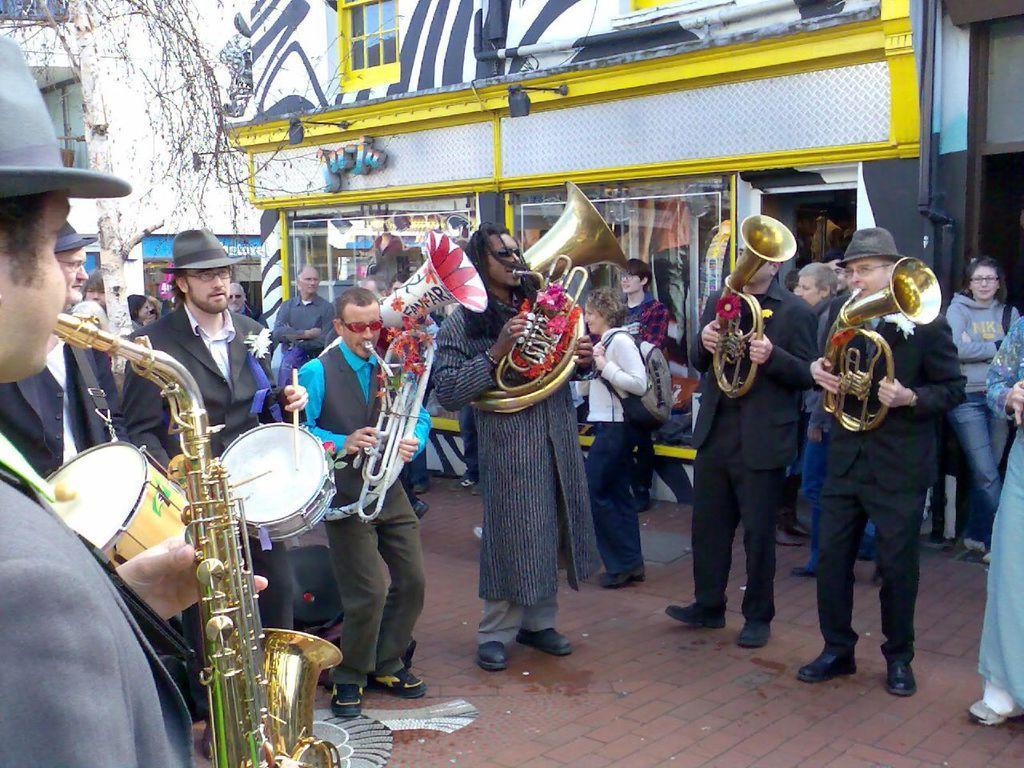How would you summarize this image in a sentence or two? In this image, we can see a group of people wearing clothes and playing musical instruments. There are some other persons standing and wearing clothes. There is a building in the middle of the image. There is a branch in the top left of the image. 